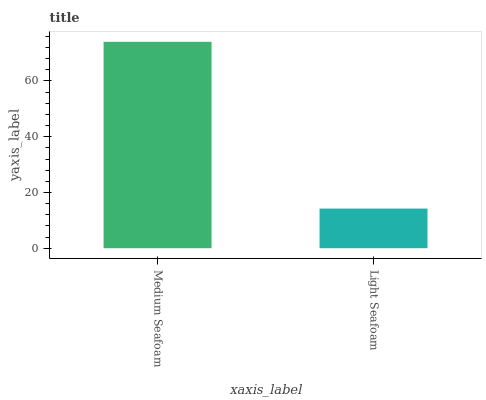Is Light Seafoam the minimum?
Answer yes or no. Yes. Is Medium Seafoam the maximum?
Answer yes or no. Yes. Is Light Seafoam the maximum?
Answer yes or no. No. Is Medium Seafoam greater than Light Seafoam?
Answer yes or no. Yes. Is Light Seafoam less than Medium Seafoam?
Answer yes or no. Yes. Is Light Seafoam greater than Medium Seafoam?
Answer yes or no. No. Is Medium Seafoam less than Light Seafoam?
Answer yes or no. No. Is Medium Seafoam the high median?
Answer yes or no. Yes. Is Light Seafoam the low median?
Answer yes or no. Yes. Is Light Seafoam the high median?
Answer yes or no. No. Is Medium Seafoam the low median?
Answer yes or no. No. 